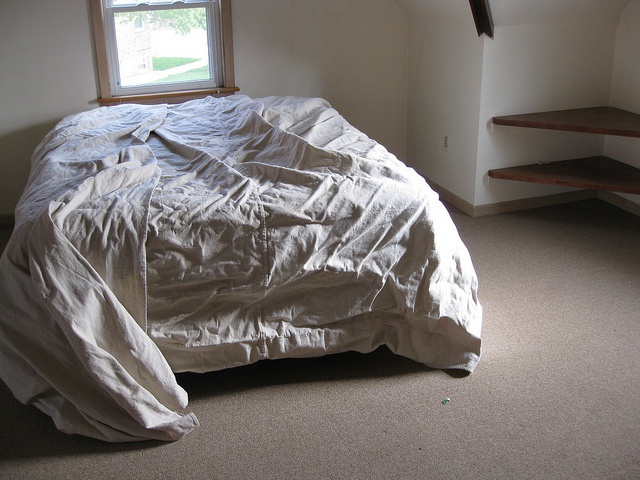Describe the objects in this image and their specific colors. I can see a bed in gray, darkgray, lightgray, and black tones in this image. 